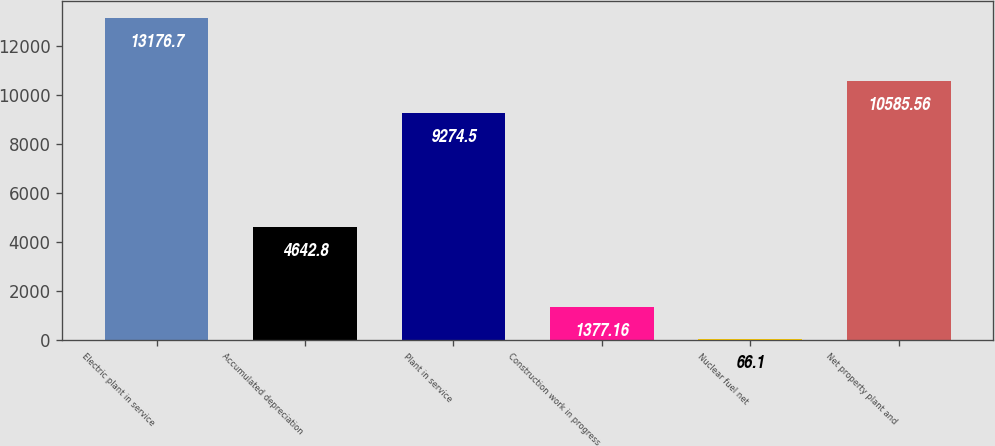Convert chart. <chart><loc_0><loc_0><loc_500><loc_500><bar_chart><fcel>Electric plant in service<fcel>Accumulated depreciation<fcel>Plant in service<fcel>Construction work in progress<fcel>Nuclear fuel net<fcel>Net property plant and<nl><fcel>13176.7<fcel>4642.8<fcel>9274.5<fcel>1377.16<fcel>66.1<fcel>10585.6<nl></chart> 